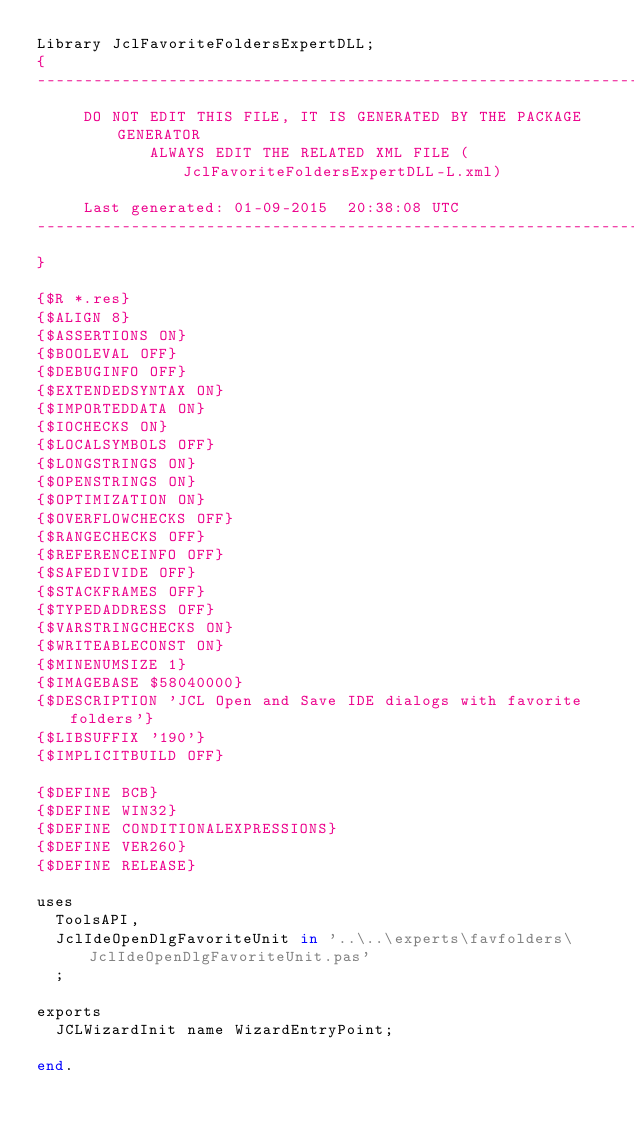<code> <loc_0><loc_0><loc_500><loc_500><_Pascal_>Library JclFavoriteFoldersExpertDLL;
{
-----------------------------------------------------------------------------
     DO NOT EDIT THIS FILE, IT IS GENERATED BY THE PACKAGE GENERATOR
            ALWAYS EDIT THE RELATED XML FILE (JclFavoriteFoldersExpertDLL-L.xml)

     Last generated: 01-09-2015  20:38:08 UTC
-----------------------------------------------------------------------------
}

{$R *.res}
{$ALIGN 8}
{$ASSERTIONS ON}
{$BOOLEVAL OFF}
{$DEBUGINFO OFF}
{$EXTENDEDSYNTAX ON}
{$IMPORTEDDATA ON}
{$IOCHECKS ON}
{$LOCALSYMBOLS OFF}
{$LONGSTRINGS ON}
{$OPENSTRINGS ON}
{$OPTIMIZATION ON}
{$OVERFLOWCHECKS OFF}
{$RANGECHECKS OFF}
{$REFERENCEINFO OFF}
{$SAFEDIVIDE OFF}
{$STACKFRAMES OFF}
{$TYPEDADDRESS OFF}
{$VARSTRINGCHECKS ON}
{$WRITEABLECONST ON}
{$MINENUMSIZE 1}
{$IMAGEBASE $58040000}
{$DESCRIPTION 'JCL Open and Save IDE dialogs with favorite folders'}
{$LIBSUFFIX '190'}
{$IMPLICITBUILD OFF}

{$DEFINE BCB}
{$DEFINE WIN32}
{$DEFINE CONDITIONALEXPRESSIONS}
{$DEFINE VER260}
{$DEFINE RELEASE}

uses
  ToolsAPI,
  JclIdeOpenDlgFavoriteUnit in '..\..\experts\favfolders\JclIdeOpenDlgFavoriteUnit.pas' 
  ;

exports
  JCLWizardInit name WizardEntryPoint;

end.
</code> 